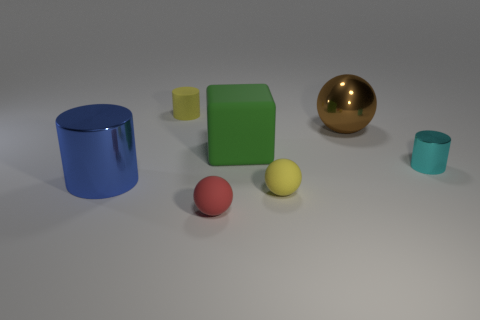Add 3 big blue cylinders. How many objects exist? 10 Subtract all yellow cylinders. How many cylinders are left? 2 Subtract all yellow balls. How many balls are left? 2 Subtract all spheres. How many objects are left? 4 Subtract 3 cylinders. How many cylinders are left? 0 Subtract all gray blocks. Subtract all gray balls. How many blocks are left? 1 Subtract all green cubes. How many red balls are left? 1 Subtract all cylinders. Subtract all tiny metallic cylinders. How many objects are left? 3 Add 6 small metal cylinders. How many small metal cylinders are left? 7 Add 4 large cyan cylinders. How many large cyan cylinders exist? 4 